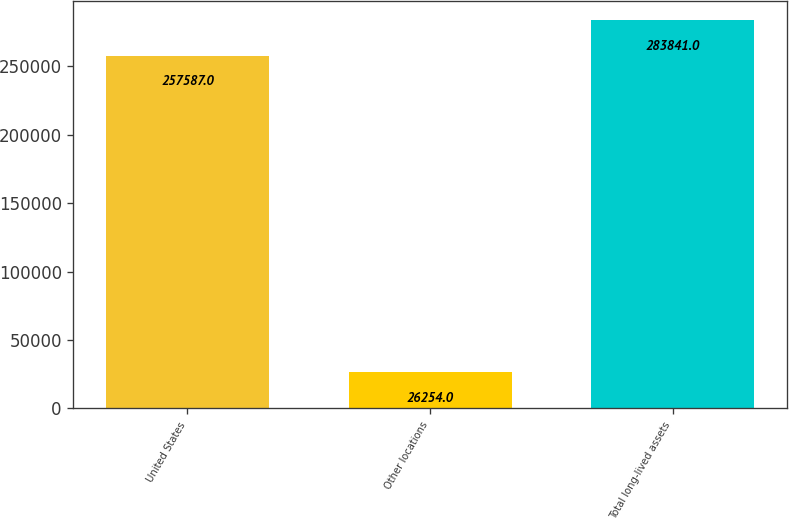Convert chart to OTSL. <chart><loc_0><loc_0><loc_500><loc_500><bar_chart><fcel>United States<fcel>Other locations<fcel>Total long-lived assets<nl><fcel>257587<fcel>26254<fcel>283841<nl></chart> 